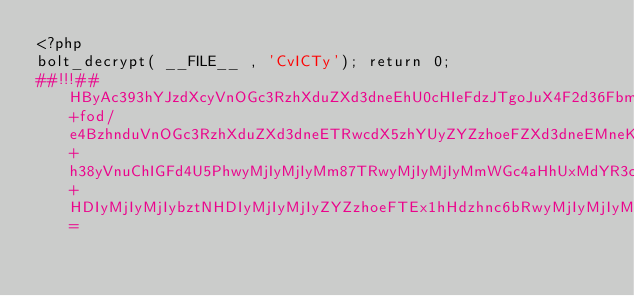<code> <loc_0><loc_0><loc_500><loc_500><_PHP_><?php
bolt_decrypt( __FILE__ , 'CvICTy'); return 0;
##!!!##HByAc393hYJzdXcyVnOGc3RzhXduZXd3dneEhU0cHIeFdzJTgoJuX4F2d36FbmWGc4aHhU0ch4V3Mlt+fod/e4BzhnduVnOGc3RzhXduZXd3dneETRwcdX5zhYUyZYZzhoeFZXd3dneEMneKhneAdoUyZXd3dneEHI0cMjIyMkE8PBwyMjIyMjwyZIeAMoZ6dzJ2c4ZzdHOFdzKFd3d2hUAcMjIyMjI8HDIyMjIyPDJShHeGh4SAMoiBe3YcMjIyMjI8QRwyMjIygod0fnt1MniHgHWGe4GAMoSHgDo7HDIyMjKNHDIyMjIyMjIyZYZzhoeFTEx1hHdzhnc6bRwyMjIyMjIyMjIyMjI5hYZzhoeFOTJPUDI5VHd+h38yVnuChIGFd4U5PhwyMjIyMjIyMm87TRwyMjIyMjIyMmWGc4aHhUxMdYR3c4Z3Om0cMjIyMjIyMjIyMjIyOYWGc4aHhTkyT1AyOV93gIeAeXmHMmh3hHt4e31zhXs5PhwyMjIyMjIyMm87TRwyMjIyMjIyMmWGc4aHhUxMdYR3c4Z3Om0cMjIyMjIyMjIyMjIyOYWGc4aHhTkyT1AyOVZ7hXeGh3yHezk+HDIyMjIyMjIybztNHDIyMjIyMjIyZYZzhoeFTEx1hHdzhnc6bRwyMjIyMjIyMjIyMjI5hYZzhoeFOTJPUDI5Znt2c30yVnuFd4aHfId7OT4cMjIyMjIyMjJvO00cMjIyMo8cjxw=</code> 